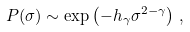<formula> <loc_0><loc_0><loc_500><loc_500>P ( \sigma ) \sim \exp \left ( - h _ { \gamma } \sigma ^ { 2 - \gamma } \right ) \, ,</formula> 